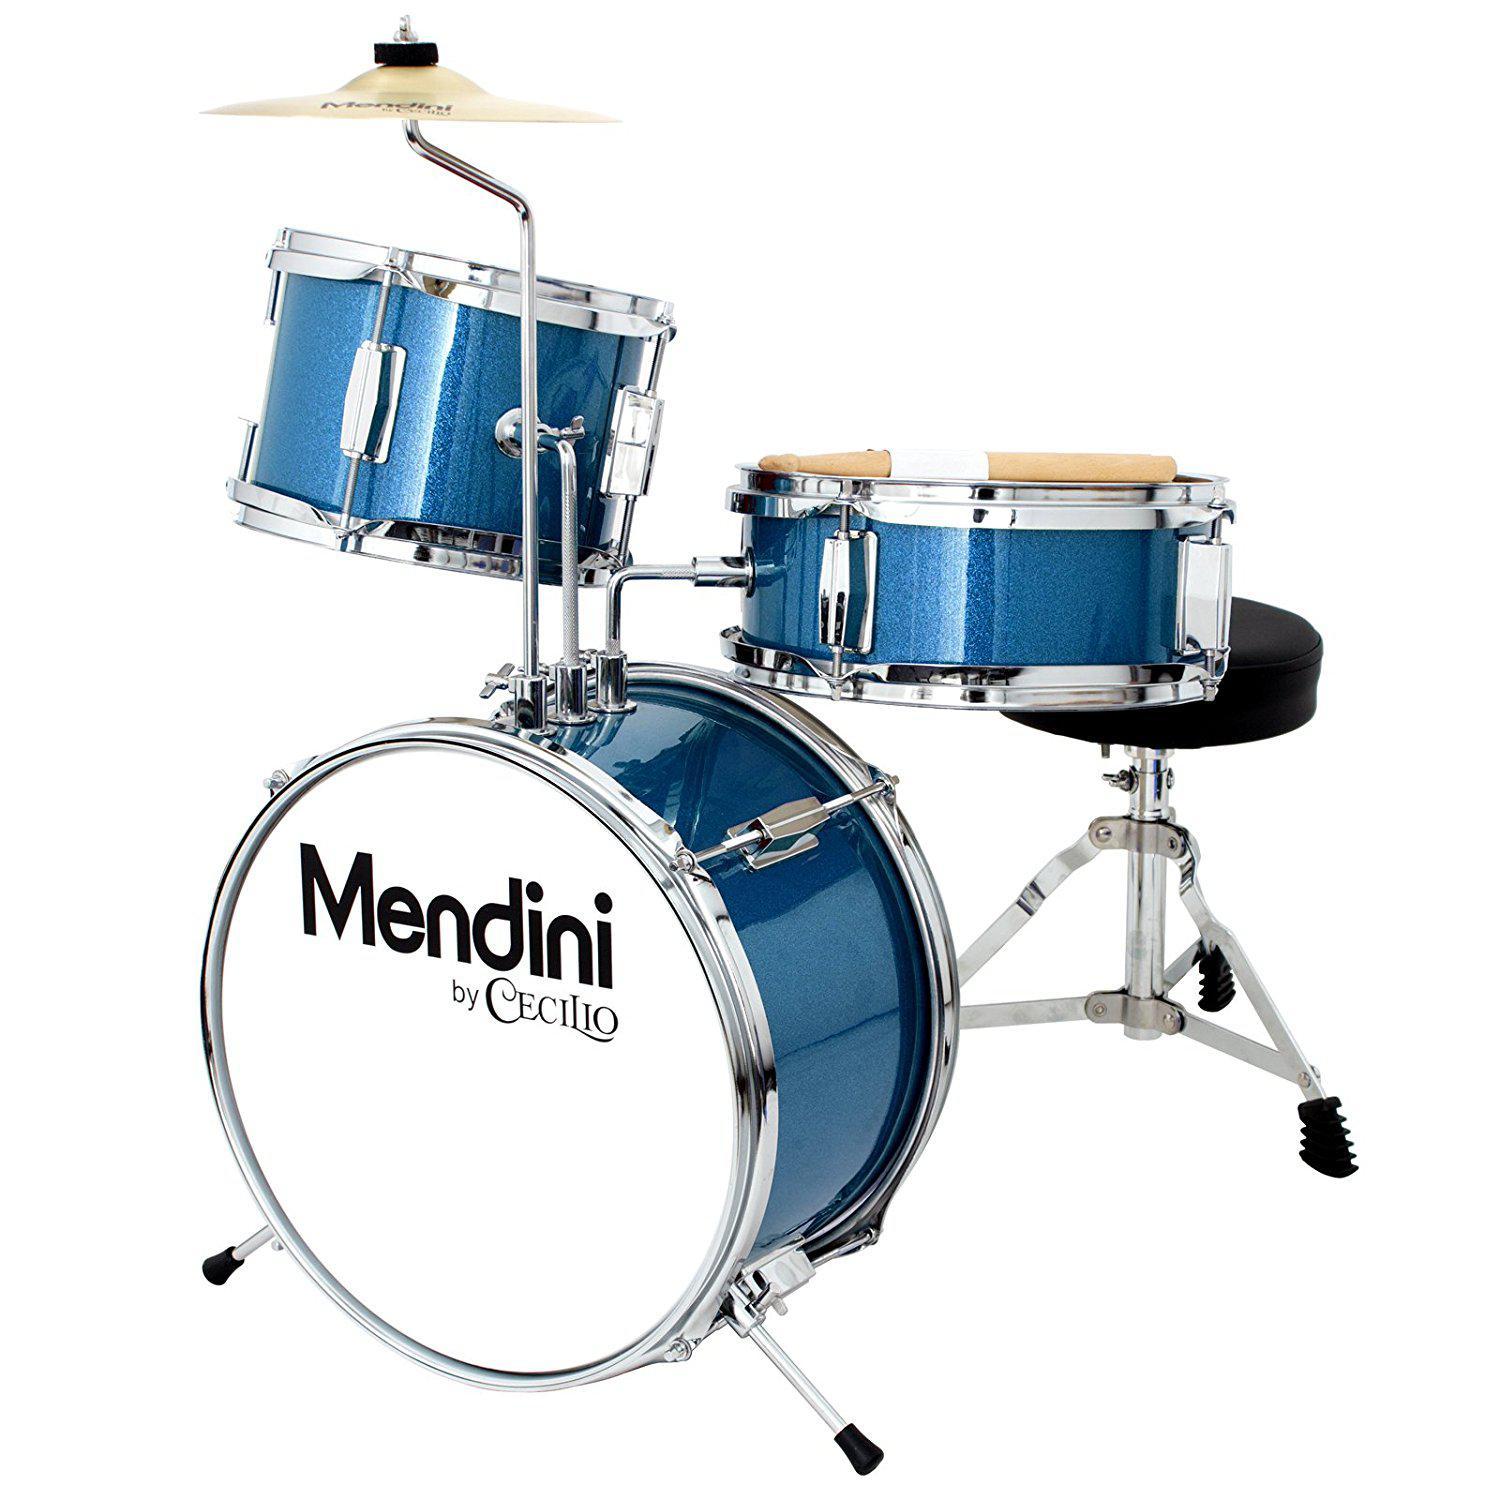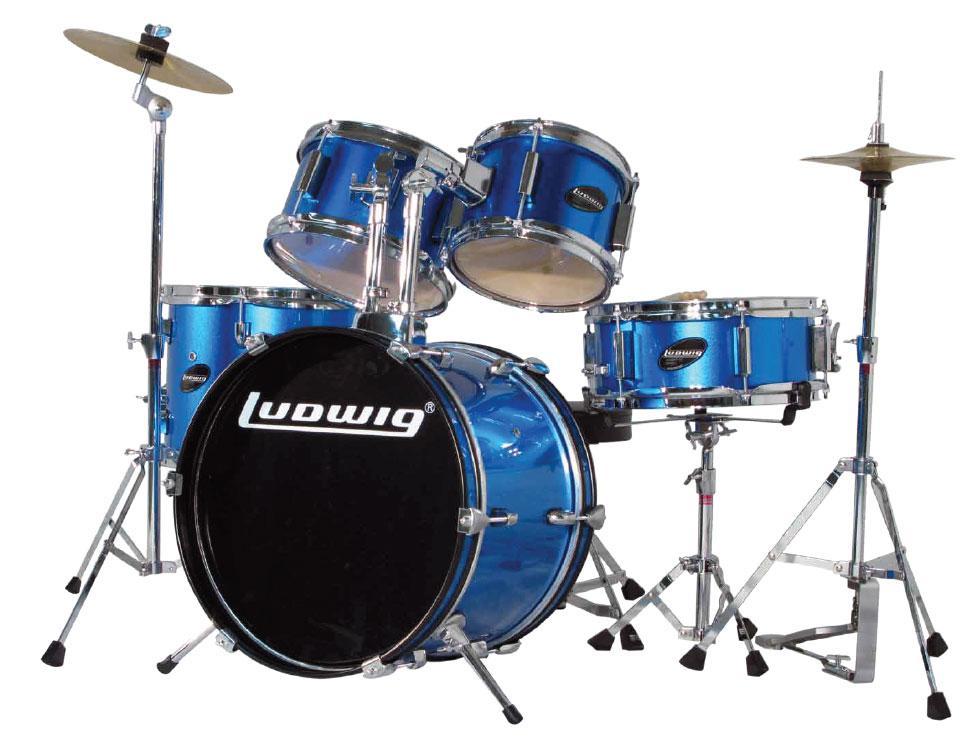The first image is the image on the left, the second image is the image on the right. Assess this claim about the two images: "In at least one image there are five blue drums.". Correct or not? Answer yes or no. Yes. The first image is the image on the left, the second image is the image on the right. Examine the images to the left and right. Is the description "The drum kits on the left and right each have exactly one large central drum that stands with a side facing the front, and that exposed side has the same color in each image." accurate? Answer yes or no. No. 